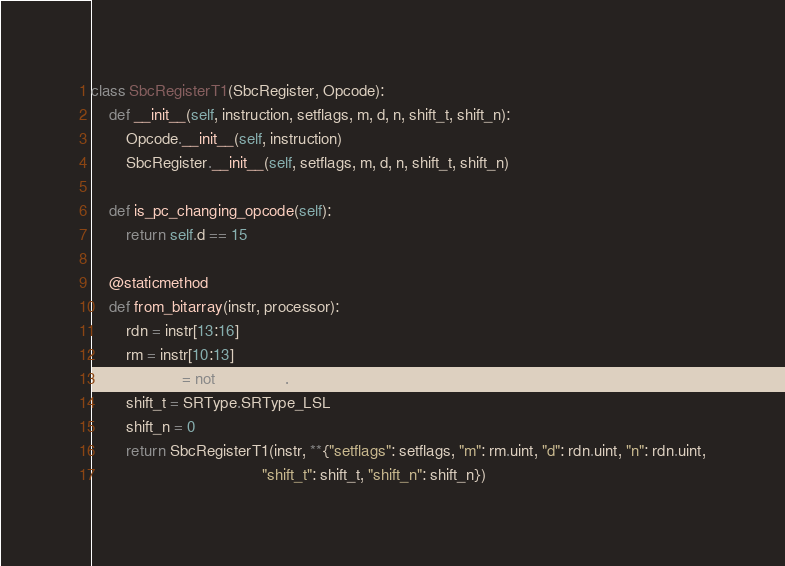<code> <loc_0><loc_0><loc_500><loc_500><_Python_>class SbcRegisterT1(SbcRegister, Opcode):
    def __init__(self, instruction, setflags, m, d, n, shift_t, shift_n):
        Opcode.__init__(self, instruction)
        SbcRegister.__init__(self, setflags, m, d, n, shift_t, shift_n)

    def is_pc_changing_opcode(self):
        return self.d == 15

    @staticmethod
    def from_bitarray(instr, processor):
        rdn = instr[13:16]
        rm = instr[10:13]
        setflags = not processor.in_it_block()
        shift_t = SRType.SRType_LSL
        shift_n = 0
        return SbcRegisterT1(instr, **{"setflags": setflags, "m": rm.uint, "d": rdn.uint, "n": rdn.uint,
                                       "shift_t": shift_t, "shift_n": shift_n})
</code> 